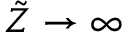<formula> <loc_0><loc_0><loc_500><loc_500>\tilde { Z } \to \infty</formula> 